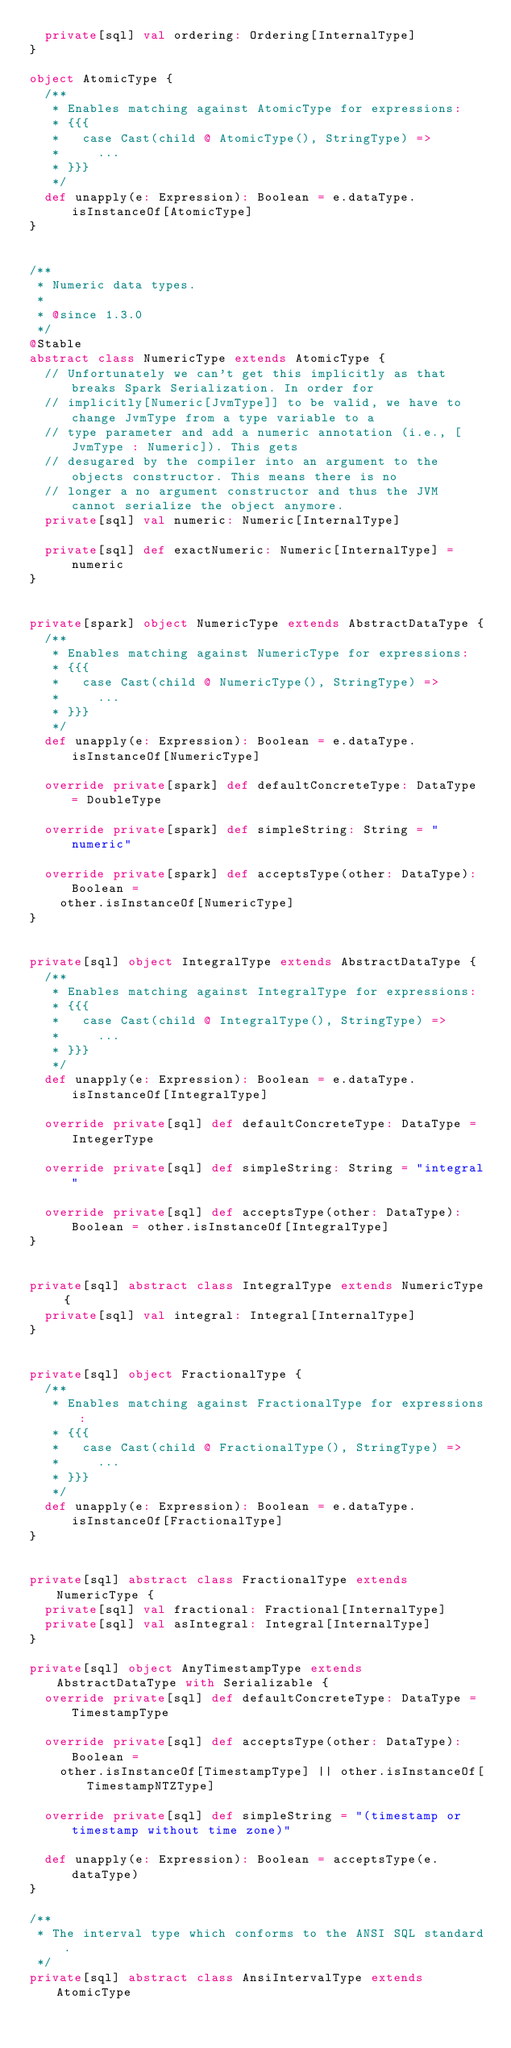Convert code to text. <code><loc_0><loc_0><loc_500><loc_500><_Scala_>  private[sql] val ordering: Ordering[InternalType]
}

object AtomicType {
  /**
   * Enables matching against AtomicType for expressions:
   * {{{
   *   case Cast(child @ AtomicType(), StringType) =>
   *     ...
   * }}}
   */
  def unapply(e: Expression): Boolean = e.dataType.isInstanceOf[AtomicType]
}


/**
 * Numeric data types.
 *
 * @since 1.3.0
 */
@Stable
abstract class NumericType extends AtomicType {
  // Unfortunately we can't get this implicitly as that breaks Spark Serialization. In order for
  // implicitly[Numeric[JvmType]] to be valid, we have to change JvmType from a type variable to a
  // type parameter and add a numeric annotation (i.e., [JvmType : Numeric]). This gets
  // desugared by the compiler into an argument to the objects constructor. This means there is no
  // longer a no argument constructor and thus the JVM cannot serialize the object anymore.
  private[sql] val numeric: Numeric[InternalType]

  private[sql] def exactNumeric: Numeric[InternalType] = numeric
}


private[spark] object NumericType extends AbstractDataType {
  /**
   * Enables matching against NumericType for expressions:
   * {{{
   *   case Cast(child @ NumericType(), StringType) =>
   *     ...
   * }}}
   */
  def unapply(e: Expression): Boolean = e.dataType.isInstanceOf[NumericType]

  override private[spark] def defaultConcreteType: DataType = DoubleType

  override private[spark] def simpleString: String = "numeric"

  override private[spark] def acceptsType(other: DataType): Boolean =
    other.isInstanceOf[NumericType]
}


private[sql] object IntegralType extends AbstractDataType {
  /**
   * Enables matching against IntegralType for expressions:
   * {{{
   *   case Cast(child @ IntegralType(), StringType) =>
   *     ...
   * }}}
   */
  def unapply(e: Expression): Boolean = e.dataType.isInstanceOf[IntegralType]

  override private[sql] def defaultConcreteType: DataType = IntegerType

  override private[sql] def simpleString: String = "integral"

  override private[sql] def acceptsType(other: DataType): Boolean = other.isInstanceOf[IntegralType]
}


private[sql] abstract class IntegralType extends NumericType {
  private[sql] val integral: Integral[InternalType]
}


private[sql] object FractionalType {
  /**
   * Enables matching against FractionalType for expressions:
   * {{{
   *   case Cast(child @ FractionalType(), StringType) =>
   *     ...
   * }}}
   */
  def unapply(e: Expression): Boolean = e.dataType.isInstanceOf[FractionalType]
}


private[sql] abstract class FractionalType extends NumericType {
  private[sql] val fractional: Fractional[InternalType]
  private[sql] val asIntegral: Integral[InternalType]
}

private[sql] object AnyTimestampType extends AbstractDataType with Serializable {
  override private[sql] def defaultConcreteType: DataType = TimestampType

  override private[sql] def acceptsType(other: DataType): Boolean =
    other.isInstanceOf[TimestampType] || other.isInstanceOf[TimestampNTZType]

  override private[sql] def simpleString = "(timestamp or timestamp without time zone)"

  def unapply(e: Expression): Boolean = acceptsType(e.dataType)
}

/**
 * The interval type which conforms to the ANSI SQL standard.
 */
private[sql] abstract class AnsiIntervalType extends AtomicType
</code> 